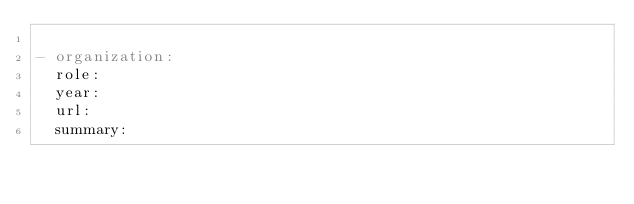<code> <loc_0><loc_0><loc_500><loc_500><_YAML_>
- organization: 
  role: 
  year: 
  url: 
  summary: 
</code> 